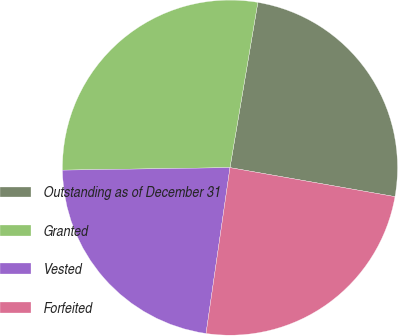<chart> <loc_0><loc_0><loc_500><loc_500><pie_chart><fcel>Outstanding as of December 31<fcel>Granted<fcel>Vested<fcel>Forfeited<nl><fcel>25.11%<fcel>27.9%<fcel>22.48%<fcel>24.51%<nl></chart> 